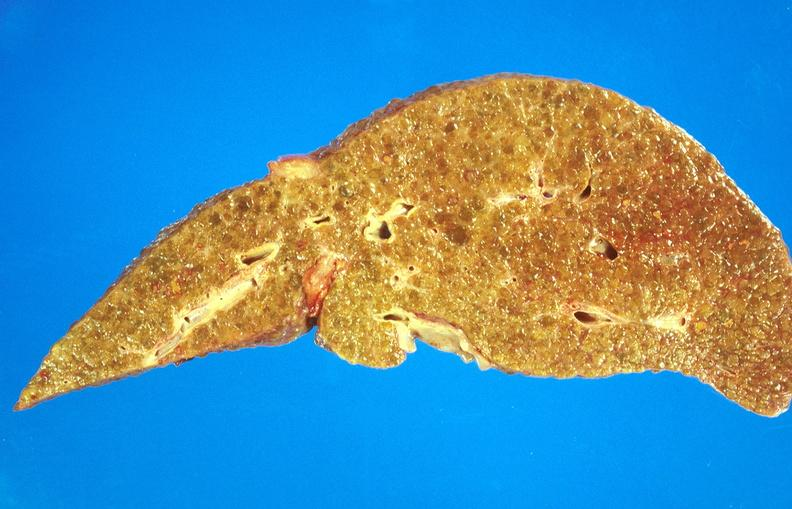what does this image show?
Answer the question using a single word or phrase. Alcoholic cirrhosis 